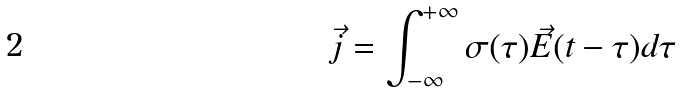<formula> <loc_0><loc_0><loc_500><loc_500>\vec { j } = \int _ { - \infty } ^ { + \infty } \sigma ( \tau ) \vec { E } ( t - \tau ) d \tau</formula> 